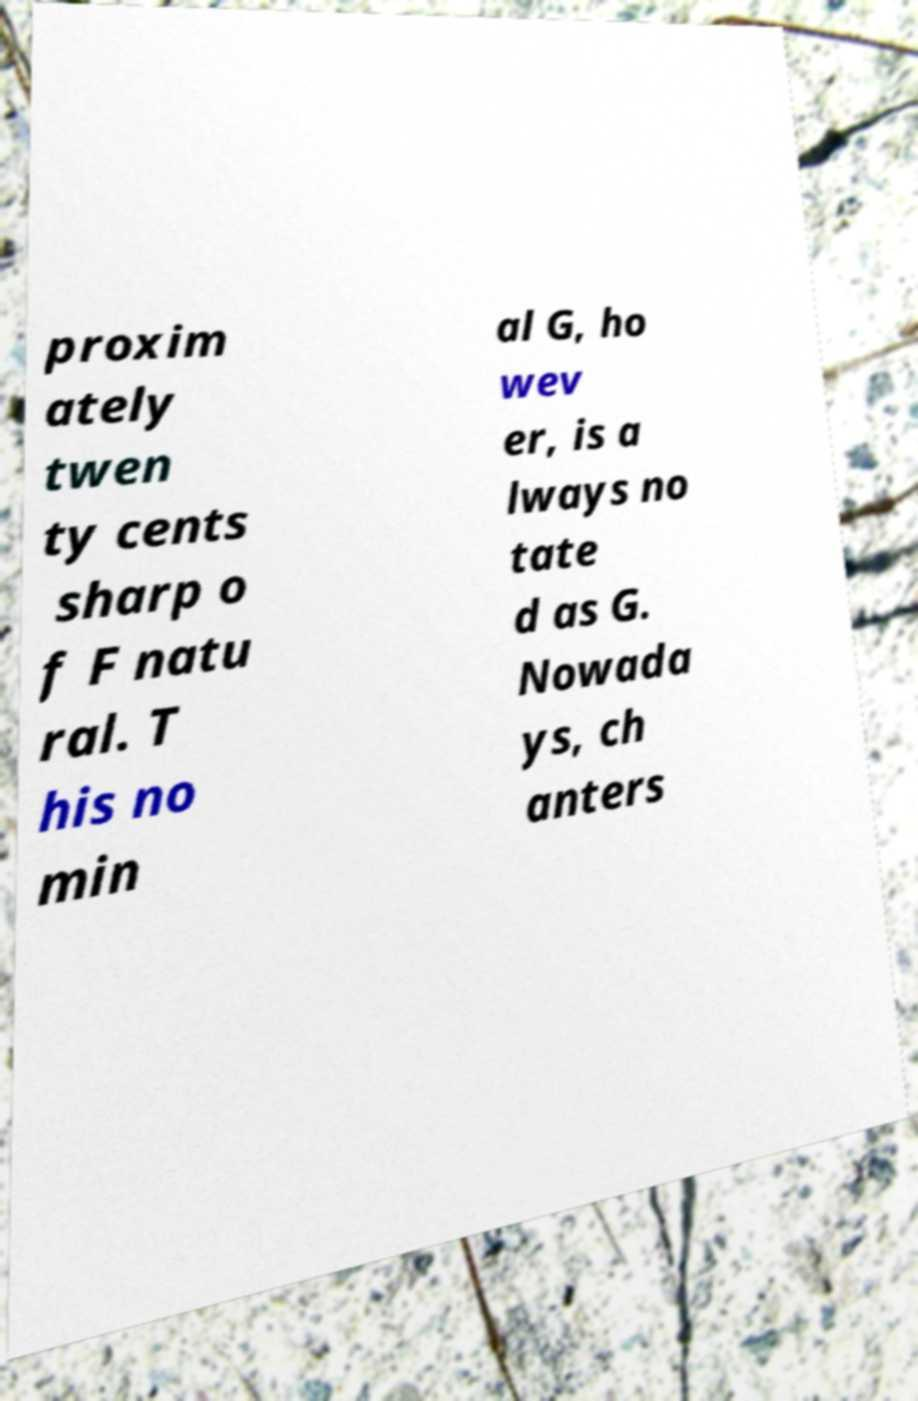Please read and relay the text visible in this image. What does it say? proxim ately twen ty cents sharp o f F natu ral. T his no min al G, ho wev er, is a lways no tate d as G. Nowada ys, ch anters 